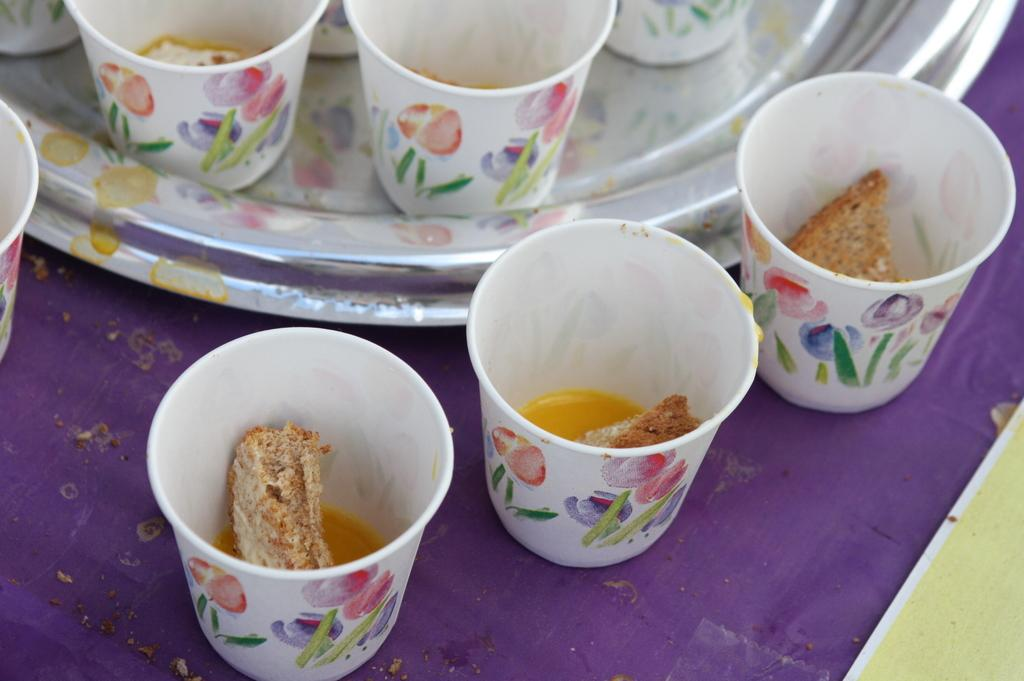What object is present in the image that can hold multiple items? There is a tray in the image that can hold multiple items. What is the current state of the cups on the tray? The cups on the tray are empty. What type of beverage is in the cup on the table? There is tea in the cup on the table. What food item is present in the cup with tea? There is a rusk in the cup with tea. What type of needle is being used to sew the cattle in the image? There is no needle or cattle present in the image. What color is the lipstick on the person's lips in the image? There are no people or lipstick present in the image. 